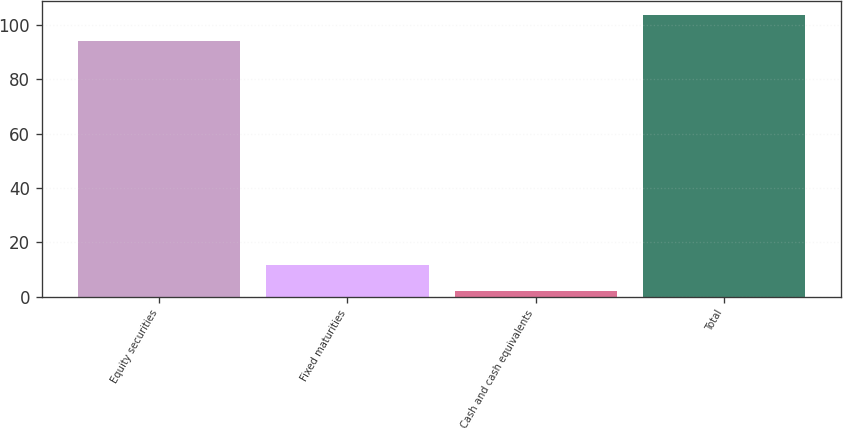Convert chart. <chart><loc_0><loc_0><loc_500><loc_500><bar_chart><fcel>Equity securities<fcel>Fixed maturities<fcel>Cash and cash equivalents<fcel>Total<nl><fcel>94<fcel>11.8<fcel>2<fcel>103.8<nl></chart> 